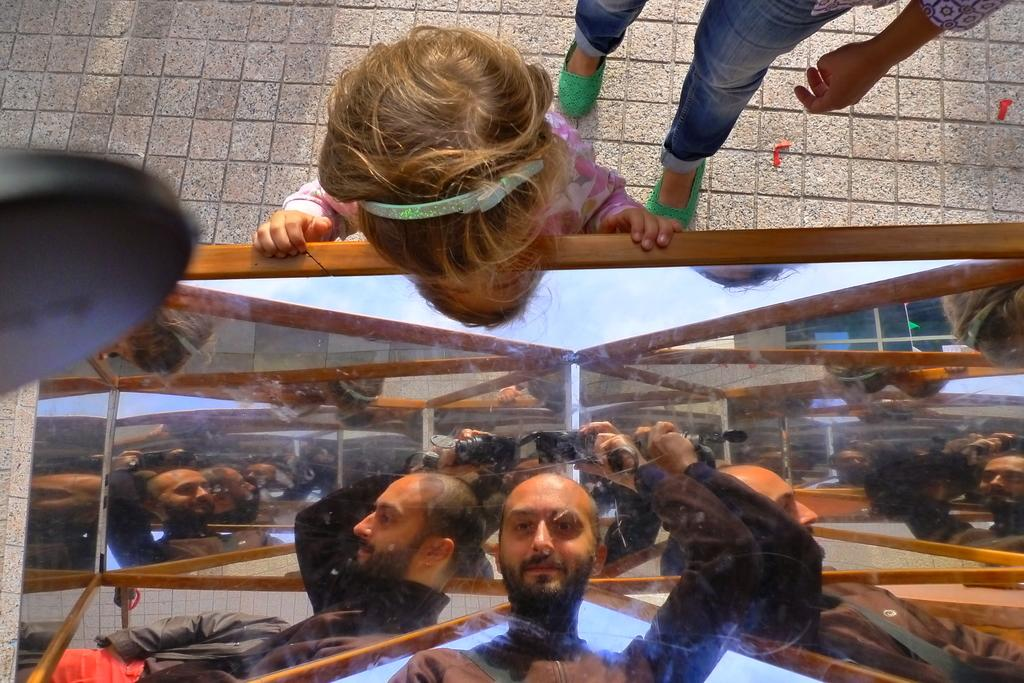What is the main subject of the image? The main subject of the image is a person inside a glass. How is the person inside the glass being observed? There is a child looking at the person in the image. What is the mass of the glass in the image? The mass of the glass cannot be determined from the image alone, as it would require additional information or context. 